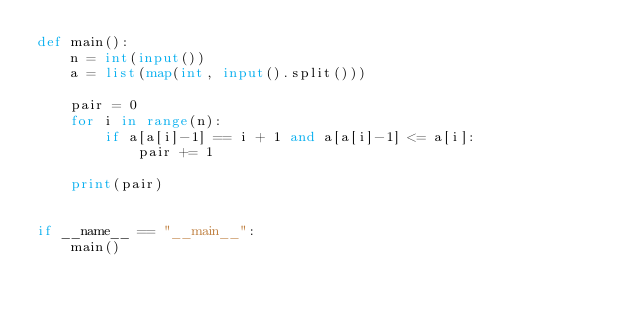Convert code to text. <code><loc_0><loc_0><loc_500><loc_500><_Python_>def main():
    n = int(input())
    a = list(map(int, input().split()))
    
    pair = 0
    for i in range(n):
        if a[a[i]-1] == i + 1 and a[a[i]-1] <= a[i]:
            pair += 1
            
    print(pair)
    
    
if __name__ == "__main__":
    main()</code> 